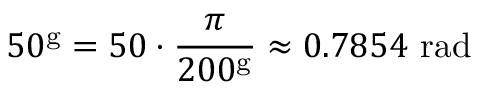<formula> <loc_0><loc_0><loc_500><loc_500>5 0 ^ { g } = 5 0 \cdot { \frac { \pi } { 2 0 0 ^ { g } } } \approx 0 . 7 8 5 4 { r a d }</formula> 